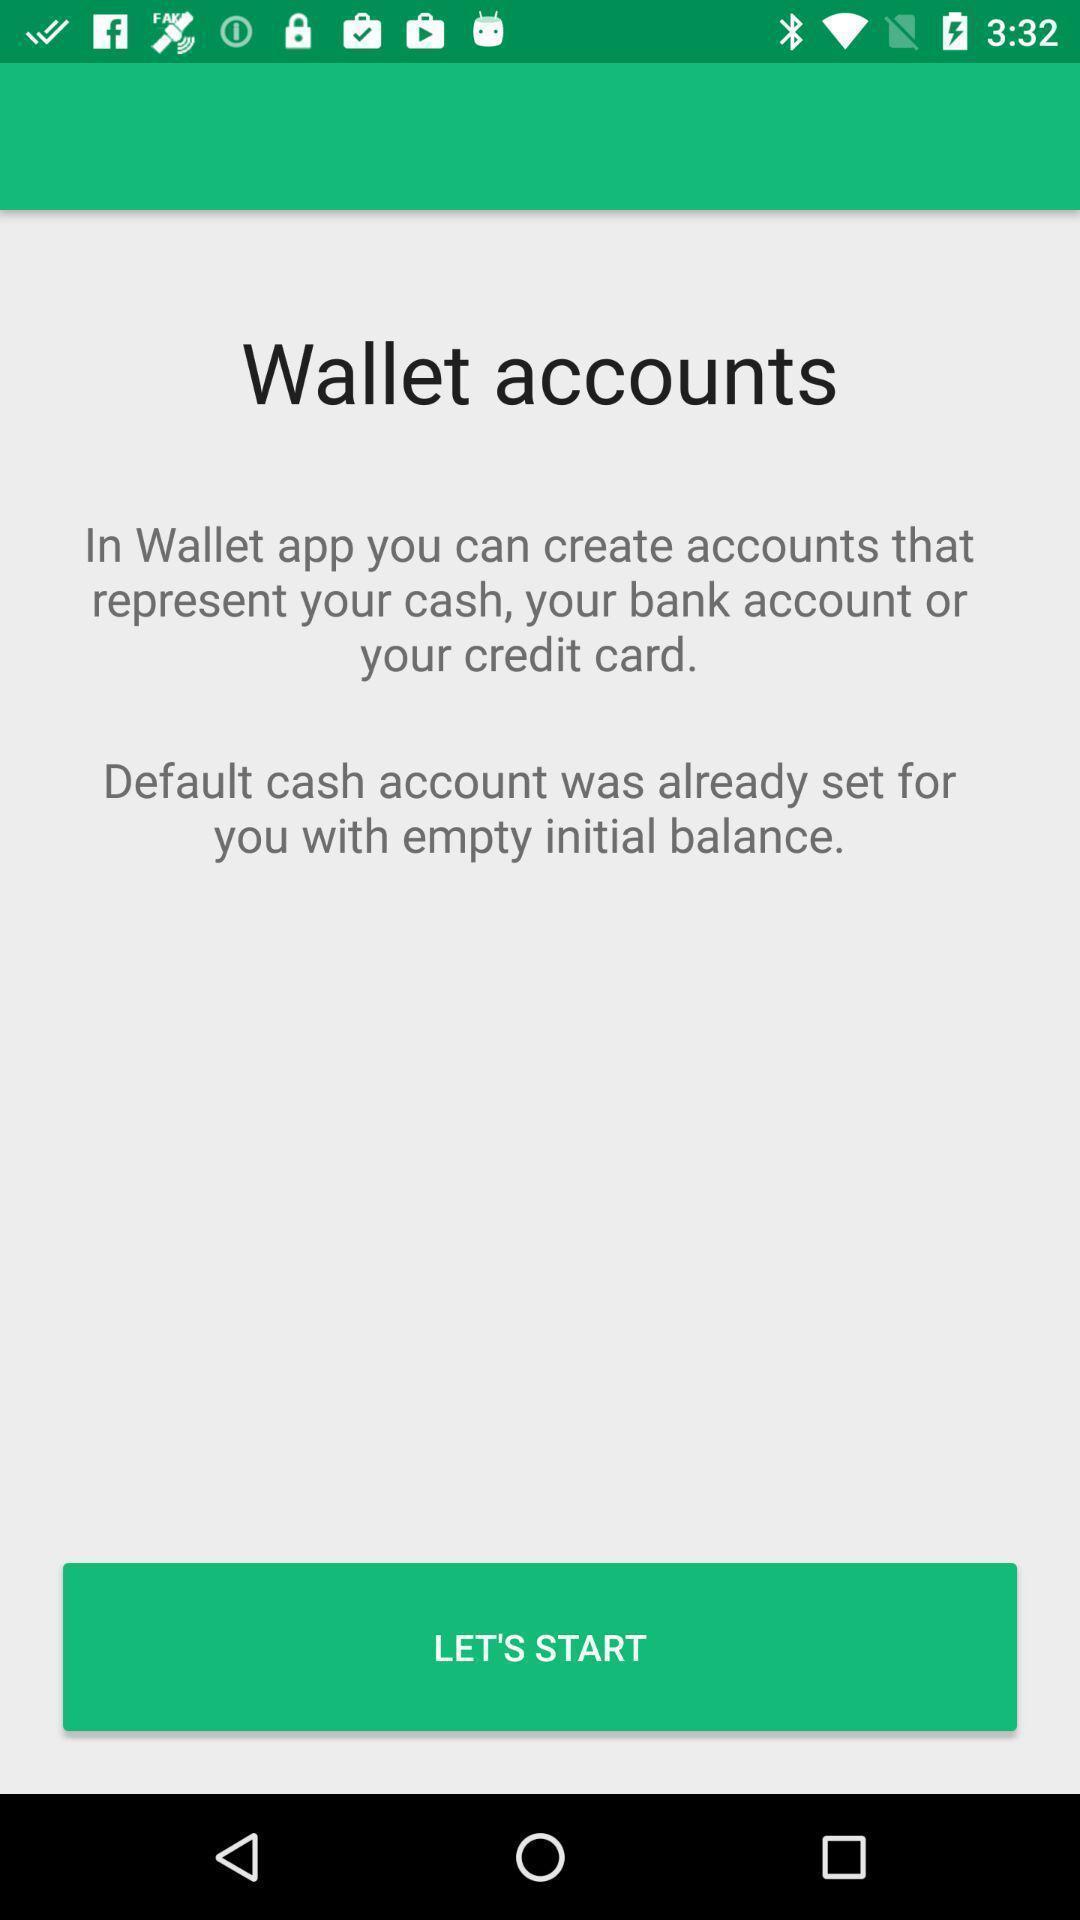Explain the elements present in this screenshot. Welcome page of financial app. 